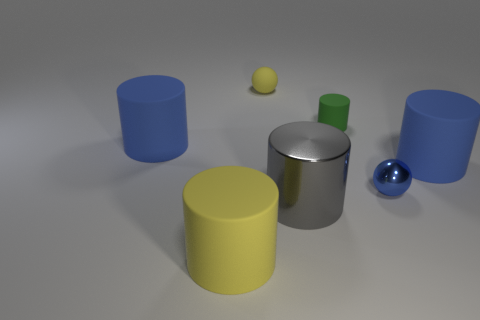There is a gray cylinder that is the same size as the yellow cylinder; what is it made of?
Your answer should be very brief. Metal. What number of tiny objects are either green cylinders or gray cylinders?
Provide a short and direct response. 1. What number of objects are large blue things that are on the left side of the tiny blue metallic sphere or things left of the tiny yellow object?
Make the answer very short. 2. Is the number of gray things less than the number of blue rubber cylinders?
Provide a short and direct response. Yes. What shape is the yellow object that is the same size as the gray shiny cylinder?
Your answer should be compact. Cylinder. How many other things are there of the same color as the large metal thing?
Provide a succinct answer. 0. What number of blue matte cylinders are there?
Your answer should be compact. 2. What number of tiny spheres are in front of the small green thing and to the left of the big gray shiny object?
Give a very brief answer. 0. What is the tiny blue object made of?
Offer a terse response. Metal. Is there a small purple metallic cylinder?
Your answer should be very brief. No. 